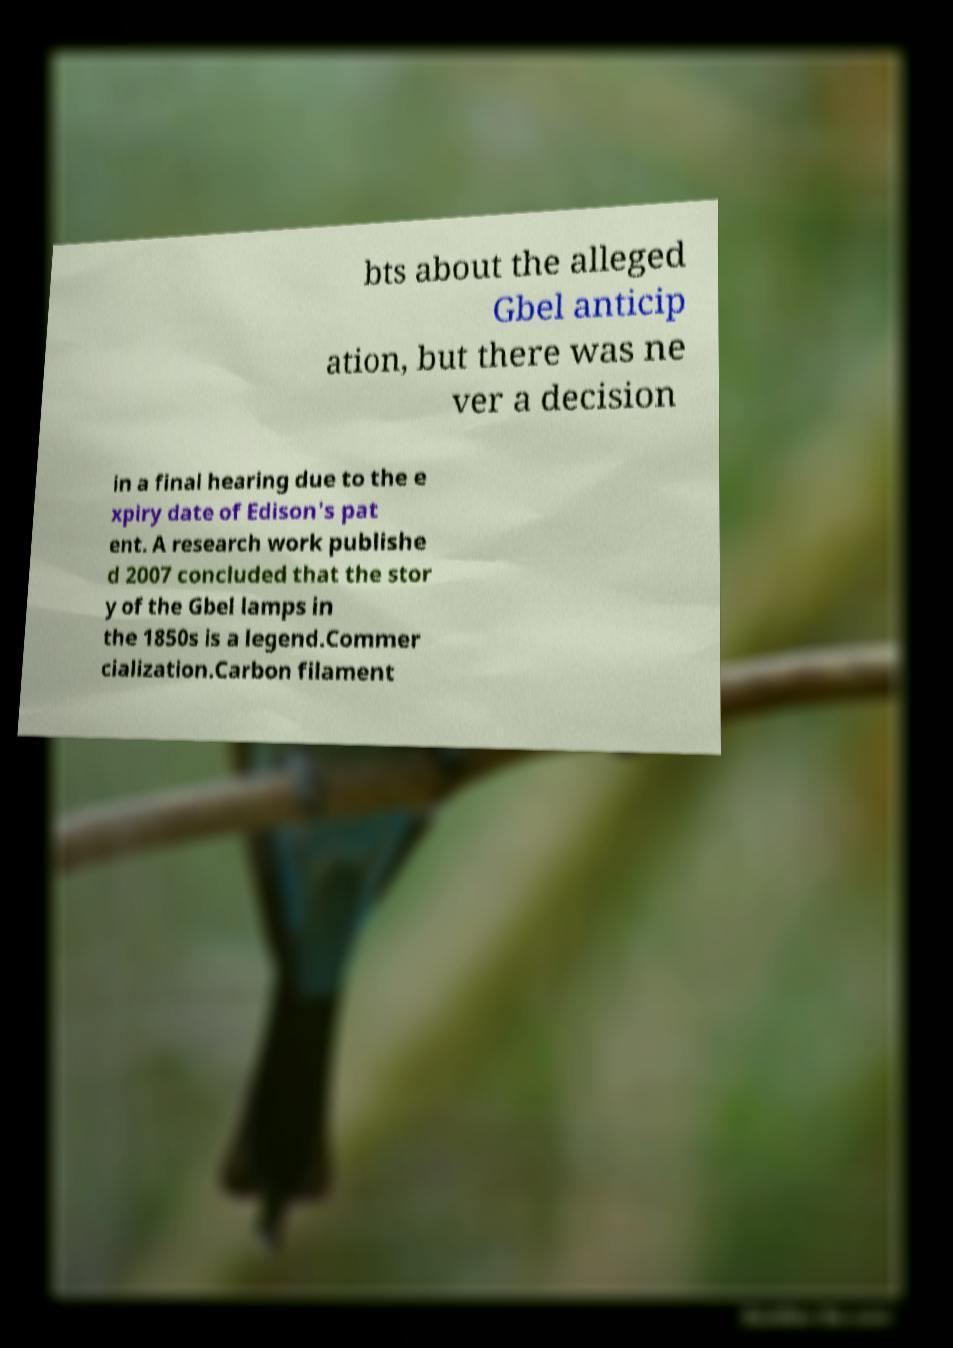Please read and relay the text visible in this image. What does it say? bts about the alleged Gbel anticip ation, but there was ne ver a decision in a final hearing due to the e xpiry date of Edison's pat ent. A research work publishe d 2007 concluded that the stor y of the Gbel lamps in the 1850s is a legend.Commer cialization.Carbon filament 